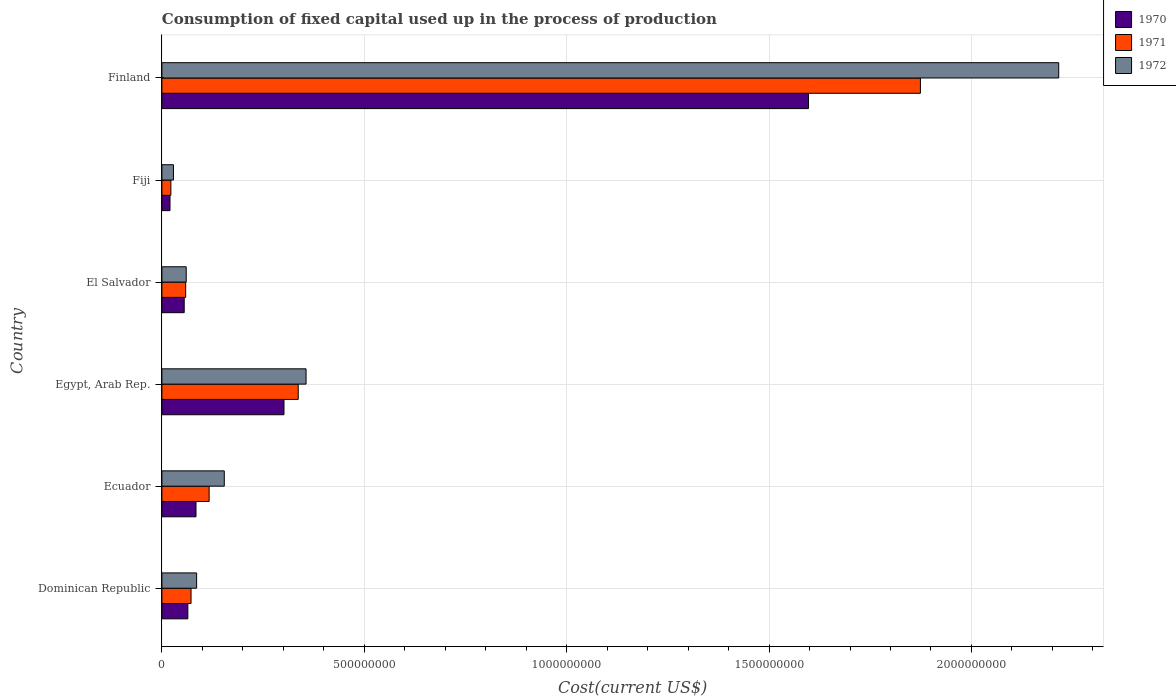How many groups of bars are there?
Your answer should be very brief. 6. What is the label of the 4th group of bars from the top?
Offer a very short reply. Egypt, Arab Rep. In how many cases, is the number of bars for a given country not equal to the number of legend labels?
Make the answer very short. 0. What is the amount consumed in the process of production in 1971 in Ecuador?
Offer a terse response. 1.17e+08. Across all countries, what is the maximum amount consumed in the process of production in 1971?
Ensure brevity in your answer.  1.87e+09. Across all countries, what is the minimum amount consumed in the process of production in 1970?
Provide a succinct answer. 2.00e+07. In which country was the amount consumed in the process of production in 1971 maximum?
Give a very brief answer. Finland. In which country was the amount consumed in the process of production in 1970 minimum?
Make the answer very short. Fiji. What is the total amount consumed in the process of production in 1971 in the graph?
Your answer should be compact. 2.48e+09. What is the difference between the amount consumed in the process of production in 1971 in Ecuador and that in Egypt, Arab Rep.?
Give a very brief answer. -2.20e+08. What is the difference between the amount consumed in the process of production in 1970 in Fiji and the amount consumed in the process of production in 1972 in Egypt, Arab Rep.?
Offer a terse response. -3.36e+08. What is the average amount consumed in the process of production in 1970 per country?
Your answer should be compact. 3.54e+08. What is the difference between the amount consumed in the process of production in 1970 and amount consumed in the process of production in 1971 in Egypt, Arab Rep.?
Your answer should be compact. -3.52e+07. In how many countries, is the amount consumed in the process of production in 1970 greater than 1800000000 US$?
Ensure brevity in your answer.  0. What is the ratio of the amount consumed in the process of production in 1970 in Egypt, Arab Rep. to that in Fiji?
Keep it short and to the point. 15.06. What is the difference between the highest and the second highest amount consumed in the process of production in 1971?
Give a very brief answer. 1.54e+09. What is the difference between the highest and the lowest amount consumed in the process of production in 1970?
Your response must be concise. 1.58e+09. How many bars are there?
Your response must be concise. 18. Does the graph contain any zero values?
Ensure brevity in your answer.  No. Does the graph contain grids?
Keep it short and to the point. Yes. Where does the legend appear in the graph?
Keep it short and to the point. Top right. How are the legend labels stacked?
Provide a succinct answer. Vertical. What is the title of the graph?
Offer a terse response. Consumption of fixed capital used up in the process of production. What is the label or title of the X-axis?
Your answer should be very brief. Cost(current US$). What is the Cost(current US$) in 1970 in Dominican Republic?
Offer a very short reply. 6.41e+07. What is the Cost(current US$) in 1971 in Dominican Republic?
Ensure brevity in your answer.  7.20e+07. What is the Cost(current US$) of 1972 in Dominican Republic?
Make the answer very short. 8.58e+07. What is the Cost(current US$) of 1970 in Ecuador?
Provide a succinct answer. 8.43e+07. What is the Cost(current US$) of 1971 in Ecuador?
Offer a terse response. 1.17e+08. What is the Cost(current US$) of 1972 in Ecuador?
Provide a short and direct response. 1.54e+08. What is the Cost(current US$) of 1970 in Egypt, Arab Rep.?
Your response must be concise. 3.02e+08. What is the Cost(current US$) in 1971 in Egypt, Arab Rep.?
Your answer should be very brief. 3.37e+08. What is the Cost(current US$) of 1972 in Egypt, Arab Rep.?
Provide a short and direct response. 3.56e+08. What is the Cost(current US$) in 1970 in El Salvador?
Keep it short and to the point. 5.51e+07. What is the Cost(current US$) of 1971 in El Salvador?
Ensure brevity in your answer.  5.88e+07. What is the Cost(current US$) of 1972 in El Salvador?
Give a very brief answer. 6.01e+07. What is the Cost(current US$) of 1970 in Fiji?
Ensure brevity in your answer.  2.00e+07. What is the Cost(current US$) of 1971 in Fiji?
Make the answer very short. 2.22e+07. What is the Cost(current US$) in 1972 in Fiji?
Keep it short and to the point. 2.86e+07. What is the Cost(current US$) in 1970 in Finland?
Keep it short and to the point. 1.60e+09. What is the Cost(current US$) in 1971 in Finland?
Provide a short and direct response. 1.87e+09. What is the Cost(current US$) in 1972 in Finland?
Offer a very short reply. 2.22e+09. Across all countries, what is the maximum Cost(current US$) of 1970?
Keep it short and to the point. 1.60e+09. Across all countries, what is the maximum Cost(current US$) of 1971?
Give a very brief answer. 1.87e+09. Across all countries, what is the maximum Cost(current US$) in 1972?
Your answer should be compact. 2.22e+09. Across all countries, what is the minimum Cost(current US$) in 1970?
Give a very brief answer. 2.00e+07. Across all countries, what is the minimum Cost(current US$) of 1971?
Provide a succinct answer. 2.22e+07. Across all countries, what is the minimum Cost(current US$) of 1972?
Provide a short and direct response. 2.86e+07. What is the total Cost(current US$) of 1970 in the graph?
Offer a terse response. 2.12e+09. What is the total Cost(current US$) in 1971 in the graph?
Offer a terse response. 2.48e+09. What is the total Cost(current US$) in 1972 in the graph?
Give a very brief answer. 2.90e+09. What is the difference between the Cost(current US$) of 1970 in Dominican Republic and that in Ecuador?
Provide a short and direct response. -2.01e+07. What is the difference between the Cost(current US$) of 1971 in Dominican Republic and that in Ecuador?
Provide a short and direct response. -4.47e+07. What is the difference between the Cost(current US$) in 1972 in Dominican Republic and that in Ecuador?
Provide a succinct answer. -6.83e+07. What is the difference between the Cost(current US$) of 1970 in Dominican Republic and that in Egypt, Arab Rep.?
Offer a very short reply. -2.37e+08. What is the difference between the Cost(current US$) of 1971 in Dominican Republic and that in Egypt, Arab Rep.?
Provide a succinct answer. -2.65e+08. What is the difference between the Cost(current US$) of 1972 in Dominican Republic and that in Egypt, Arab Rep.?
Provide a short and direct response. -2.70e+08. What is the difference between the Cost(current US$) of 1970 in Dominican Republic and that in El Salvador?
Make the answer very short. 9.05e+06. What is the difference between the Cost(current US$) in 1971 in Dominican Republic and that in El Salvador?
Offer a terse response. 1.32e+07. What is the difference between the Cost(current US$) of 1972 in Dominican Republic and that in El Salvador?
Offer a very short reply. 2.57e+07. What is the difference between the Cost(current US$) of 1970 in Dominican Republic and that in Fiji?
Your answer should be very brief. 4.41e+07. What is the difference between the Cost(current US$) of 1971 in Dominican Republic and that in Fiji?
Give a very brief answer. 4.98e+07. What is the difference between the Cost(current US$) in 1972 in Dominican Republic and that in Fiji?
Your response must be concise. 5.72e+07. What is the difference between the Cost(current US$) in 1970 in Dominican Republic and that in Finland?
Offer a very short reply. -1.53e+09. What is the difference between the Cost(current US$) in 1971 in Dominican Republic and that in Finland?
Give a very brief answer. -1.80e+09. What is the difference between the Cost(current US$) of 1972 in Dominican Republic and that in Finland?
Ensure brevity in your answer.  -2.13e+09. What is the difference between the Cost(current US$) in 1970 in Ecuador and that in Egypt, Arab Rep.?
Offer a very short reply. -2.17e+08. What is the difference between the Cost(current US$) in 1971 in Ecuador and that in Egypt, Arab Rep.?
Make the answer very short. -2.20e+08. What is the difference between the Cost(current US$) in 1972 in Ecuador and that in Egypt, Arab Rep.?
Keep it short and to the point. -2.02e+08. What is the difference between the Cost(current US$) of 1970 in Ecuador and that in El Salvador?
Your answer should be very brief. 2.92e+07. What is the difference between the Cost(current US$) of 1971 in Ecuador and that in El Salvador?
Keep it short and to the point. 5.79e+07. What is the difference between the Cost(current US$) in 1972 in Ecuador and that in El Salvador?
Your answer should be very brief. 9.40e+07. What is the difference between the Cost(current US$) of 1970 in Ecuador and that in Fiji?
Ensure brevity in your answer.  6.42e+07. What is the difference between the Cost(current US$) in 1971 in Ecuador and that in Fiji?
Provide a succinct answer. 9.45e+07. What is the difference between the Cost(current US$) of 1972 in Ecuador and that in Fiji?
Make the answer very short. 1.26e+08. What is the difference between the Cost(current US$) in 1970 in Ecuador and that in Finland?
Offer a very short reply. -1.51e+09. What is the difference between the Cost(current US$) of 1971 in Ecuador and that in Finland?
Your response must be concise. -1.76e+09. What is the difference between the Cost(current US$) of 1972 in Ecuador and that in Finland?
Your answer should be very brief. -2.06e+09. What is the difference between the Cost(current US$) of 1970 in Egypt, Arab Rep. and that in El Salvador?
Your response must be concise. 2.47e+08. What is the difference between the Cost(current US$) in 1971 in Egypt, Arab Rep. and that in El Salvador?
Give a very brief answer. 2.78e+08. What is the difference between the Cost(current US$) of 1972 in Egypt, Arab Rep. and that in El Salvador?
Keep it short and to the point. 2.96e+08. What is the difference between the Cost(current US$) in 1970 in Egypt, Arab Rep. and that in Fiji?
Keep it short and to the point. 2.82e+08. What is the difference between the Cost(current US$) in 1971 in Egypt, Arab Rep. and that in Fiji?
Offer a terse response. 3.15e+08. What is the difference between the Cost(current US$) in 1972 in Egypt, Arab Rep. and that in Fiji?
Make the answer very short. 3.28e+08. What is the difference between the Cost(current US$) of 1970 in Egypt, Arab Rep. and that in Finland?
Your answer should be compact. -1.30e+09. What is the difference between the Cost(current US$) in 1971 in Egypt, Arab Rep. and that in Finland?
Your response must be concise. -1.54e+09. What is the difference between the Cost(current US$) of 1972 in Egypt, Arab Rep. and that in Finland?
Your response must be concise. -1.86e+09. What is the difference between the Cost(current US$) in 1970 in El Salvador and that in Fiji?
Give a very brief answer. 3.51e+07. What is the difference between the Cost(current US$) in 1971 in El Salvador and that in Fiji?
Offer a terse response. 3.66e+07. What is the difference between the Cost(current US$) of 1972 in El Salvador and that in Fiji?
Offer a very short reply. 3.15e+07. What is the difference between the Cost(current US$) of 1970 in El Salvador and that in Finland?
Provide a short and direct response. -1.54e+09. What is the difference between the Cost(current US$) in 1971 in El Salvador and that in Finland?
Your answer should be very brief. -1.82e+09. What is the difference between the Cost(current US$) of 1972 in El Salvador and that in Finland?
Offer a terse response. -2.16e+09. What is the difference between the Cost(current US$) of 1970 in Fiji and that in Finland?
Make the answer very short. -1.58e+09. What is the difference between the Cost(current US$) of 1971 in Fiji and that in Finland?
Offer a very short reply. -1.85e+09. What is the difference between the Cost(current US$) of 1972 in Fiji and that in Finland?
Make the answer very short. -2.19e+09. What is the difference between the Cost(current US$) in 1970 in Dominican Republic and the Cost(current US$) in 1971 in Ecuador?
Your answer should be very brief. -5.25e+07. What is the difference between the Cost(current US$) in 1970 in Dominican Republic and the Cost(current US$) in 1972 in Ecuador?
Ensure brevity in your answer.  -9.00e+07. What is the difference between the Cost(current US$) in 1971 in Dominican Republic and the Cost(current US$) in 1972 in Ecuador?
Offer a very short reply. -8.21e+07. What is the difference between the Cost(current US$) of 1970 in Dominican Republic and the Cost(current US$) of 1971 in Egypt, Arab Rep.?
Ensure brevity in your answer.  -2.73e+08. What is the difference between the Cost(current US$) in 1970 in Dominican Republic and the Cost(current US$) in 1972 in Egypt, Arab Rep.?
Your answer should be compact. -2.92e+08. What is the difference between the Cost(current US$) in 1971 in Dominican Republic and the Cost(current US$) in 1972 in Egypt, Arab Rep.?
Make the answer very short. -2.84e+08. What is the difference between the Cost(current US$) in 1970 in Dominican Republic and the Cost(current US$) in 1971 in El Salvador?
Keep it short and to the point. 5.36e+06. What is the difference between the Cost(current US$) of 1970 in Dominican Republic and the Cost(current US$) of 1972 in El Salvador?
Your answer should be very brief. 4.06e+06. What is the difference between the Cost(current US$) of 1971 in Dominican Republic and the Cost(current US$) of 1972 in El Salvador?
Make the answer very short. 1.19e+07. What is the difference between the Cost(current US$) of 1970 in Dominican Republic and the Cost(current US$) of 1971 in Fiji?
Provide a short and direct response. 4.20e+07. What is the difference between the Cost(current US$) in 1970 in Dominican Republic and the Cost(current US$) in 1972 in Fiji?
Offer a terse response. 3.56e+07. What is the difference between the Cost(current US$) in 1971 in Dominican Republic and the Cost(current US$) in 1972 in Fiji?
Your response must be concise. 4.34e+07. What is the difference between the Cost(current US$) in 1970 in Dominican Republic and the Cost(current US$) in 1971 in Finland?
Give a very brief answer. -1.81e+09. What is the difference between the Cost(current US$) in 1970 in Dominican Republic and the Cost(current US$) in 1972 in Finland?
Offer a terse response. -2.15e+09. What is the difference between the Cost(current US$) in 1971 in Dominican Republic and the Cost(current US$) in 1972 in Finland?
Your response must be concise. -2.14e+09. What is the difference between the Cost(current US$) of 1970 in Ecuador and the Cost(current US$) of 1971 in Egypt, Arab Rep.?
Provide a succinct answer. -2.53e+08. What is the difference between the Cost(current US$) in 1970 in Ecuador and the Cost(current US$) in 1972 in Egypt, Arab Rep.?
Offer a very short reply. -2.72e+08. What is the difference between the Cost(current US$) in 1971 in Ecuador and the Cost(current US$) in 1972 in Egypt, Arab Rep.?
Make the answer very short. -2.39e+08. What is the difference between the Cost(current US$) of 1970 in Ecuador and the Cost(current US$) of 1971 in El Salvador?
Your answer should be very brief. 2.55e+07. What is the difference between the Cost(current US$) of 1970 in Ecuador and the Cost(current US$) of 1972 in El Salvador?
Offer a terse response. 2.42e+07. What is the difference between the Cost(current US$) of 1971 in Ecuador and the Cost(current US$) of 1972 in El Salvador?
Ensure brevity in your answer.  5.66e+07. What is the difference between the Cost(current US$) of 1970 in Ecuador and the Cost(current US$) of 1971 in Fiji?
Your answer should be very brief. 6.21e+07. What is the difference between the Cost(current US$) in 1970 in Ecuador and the Cost(current US$) in 1972 in Fiji?
Offer a terse response. 5.57e+07. What is the difference between the Cost(current US$) of 1971 in Ecuador and the Cost(current US$) of 1972 in Fiji?
Your answer should be very brief. 8.81e+07. What is the difference between the Cost(current US$) of 1970 in Ecuador and the Cost(current US$) of 1971 in Finland?
Your answer should be very brief. -1.79e+09. What is the difference between the Cost(current US$) of 1970 in Ecuador and the Cost(current US$) of 1972 in Finland?
Your answer should be very brief. -2.13e+09. What is the difference between the Cost(current US$) in 1971 in Ecuador and the Cost(current US$) in 1972 in Finland?
Offer a terse response. -2.10e+09. What is the difference between the Cost(current US$) in 1970 in Egypt, Arab Rep. and the Cost(current US$) in 1971 in El Salvador?
Ensure brevity in your answer.  2.43e+08. What is the difference between the Cost(current US$) of 1970 in Egypt, Arab Rep. and the Cost(current US$) of 1972 in El Salvador?
Keep it short and to the point. 2.42e+08. What is the difference between the Cost(current US$) of 1971 in Egypt, Arab Rep. and the Cost(current US$) of 1972 in El Salvador?
Provide a short and direct response. 2.77e+08. What is the difference between the Cost(current US$) in 1970 in Egypt, Arab Rep. and the Cost(current US$) in 1971 in Fiji?
Provide a short and direct response. 2.79e+08. What is the difference between the Cost(current US$) of 1970 in Egypt, Arab Rep. and the Cost(current US$) of 1972 in Fiji?
Offer a very short reply. 2.73e+08. What is the difference between the Cost(current US$) of 1971 in Egypt, Arab Rep. and the Cost(current US$) of 1972 in Fiji?
Provide a short and direct response. 3.08e+08. What is the difference between the Cost(current US$) of 1970 in Egypt, Arab Rep. and the Cost(current US$) of 1971 in Finland?
Your answer should be very brief. -1.57e+09. What is the difference between the Cost(current US$) in 1970 in Egypt, Arab Rep. and the Cost(current US$) in 1972 in Finland?
Keep it short and to the point. -1.91e+09. What is the difference between the Cost(current US$) in 1971 in Egypt, Arab Rep. and the Cost(current US$) in 1972 in Finland?
Provide a succinct answer. -1.88e+09. What is the difference between the Cost(current US$) in 1970 in El Salvador and the Cost(current US$) in 1971 in Fiji?
Your response must be concise. 3.29e+07. What is the difference between the Cost(current US$) of 1970 in El Salvador and the Cost(current US$) of 1972 in Fiji?
Provide a succinct answer. 2.65e+07. What is the difference between the Cost(current US$) in 1971 in El Salvador and the Cost(current US$) in 1972 in Fiji?
Ensure brevity in your answer.  3.02e+07. What is the difference between the Cost(current US$) of 1970 in El Salvador and the Cost(current US$) of 1971 in Finland?
Offer a very short reply. -1.82e+09. What is the difference between the Cost(current US$) in 1970 in El Salvador and the Cost(current US$) in 1972 in Finland?
Your answer should be compact. -2.16e+09. What is the difference between the Cost(current US$) in 1971 in El Salvador and the Cost(current US$) in 1972 in Finland?
Give a very brief answer. -2.16e+09. What is the difference between the Cost(current US$) in 1970 in Fiji and the Cost(current US$) in 1971 in Finland?
Make the answer very short. -1.85e+09. What is the difference between the Cost(current US$) of 1970 in Fiji and the Cost(current US$) of 1972 in Finland?
Your answer should be compact. -2.20e+09. What is the difference between the Cost(current US$) in 1971 in Fiji and the Cost(current US$) in 1972 in Finland?
Provide a succinct answer. -2.19e+09. What is the average Cost(current US$) of 1970 per country?
Your answer should be very brief. 3.54e+08. What is the average Cost(current US$) in 1971 per country?
Your answer should be compact. 4.13e+08. What is the average Cost(current US$) of 1972 per country?
Give a very brief answer. 4.83e+08. What is the difference between the Cost(current US$) in 1970 and Cost(current US$) in 1971 in Dominican Republic?
Keep it short and to the point. -7.86e+06. What is the difference between the Cost(current US$) in 1970 and Cost(current US$) in 1972 in Dominican Republic?
Your answer should be very brief. -2.17e+07. What is the difference between the Cost(current US$) of 1971 and Cost(current US$) of 1972 in Dominican Republic?
Give a very brief answer. -1.38e+07. What is the difference between the Cost(current US$) in 1970 and Cost(current US$) in 1971 in Ecuador?
Your answer should be compact. -3.24e+07. What is the difference between the Cost(current US$) of 1970 and Cost(current US$) of 1972 in Ecuador?
Your response must be concise. -6.99e+07. What is the difference between the Cost(current US$) of 1971 and Cost(current US$) of 1972 in Ecuador?
Offer a terse response. -3.74e+07. What is the difference between the Cost(current US$) in 1970 and Cost(current US$) in 1971 in Egypt, Arab Rep.?
Your answer should be compact. -3.52e+07. What is the difference between the Cost(current US$) in 1970 and Cost(current US$) in 1972 in Egypt, Arab Rep.?
Offer a terse response. -5.45e+07. What is the difference between the Cost(current US$) of 1971 and Cost(current US$) of 1972 in Egypt, Arab Rep.?
Offer a very short reply. -1.93e+07. What is the difference between the Cost(current US$) in 1970 and Cost(current US$) in 1971 in El Salvador?
Your answer should be compact. -3.70e+06. What is the difference between the Cost(current US$) in 1970 and Cost(current US$) in 1972 in El Salvador?
Give a very brief answer. -4.99e+06. What is the difference between the Cost(current US$) of 1971 and Cost(current US$) of 1972 in El Salvador?
Provide a succinct answer. -1.29e+06. What is the difference between the Cost(current US$) of 1970 and Cost(current US$) of 1971 in Fiji?
Your answer should be compact. -2.14e+06. What is the difference between the Cost(current US$) of 1970 and Cost(current US$) of 1972 in Fiji?
Offer a very short reply. -8.53e+06. What is the difference between the Cost(current US$) in 1971 and Cost(current US$) in 1972 in Fiji?
Keep it short and to the point. -6.39e+06. What is the difference between the Cost(current US$) in 1970 and Cost(current US$) in 1971 in Finland?
Provide a short and direct response. -2.77e+08. What is the difference between the Cost(current US$) in 1970 and Cost(current US$) in 1972 in Finland?
Your answer should be compact. -6.18e+08. What is the difference between the Cost(current US$) in 1971 and Cost(current US$) in 1972 in Finland?
Offer a terse response. -3.42e+08. What is the ratio of the Cost(current US$) in 1970 in Dominican Republic to that in Ecuador?
Provide a succinct answer. 0.76. What is the ratio of the Cost(current US$) in 1971 in Dominican Republic to that in Ecuador?
Give a very brief answer. 0.62. What is the ratio of the Cost(current US$) in 1972 in Dominican Republic to that in Ecuador?
Make the answer very short. 0.56. What is the ratio of the Cost(current US$) of 1970 in Dominican Republic to that in Egypt, Arab Rep.?
Provide a succinct answer. 0.21. What is the ratio of the Cost(current US$) of 1971 in Dominican Republic to that in Egypt, Arab Rep.?
Offer a very short reply. 0.21. What is the ratio of the Cost(current US$) in 1972 in Dominican Republic to that in Egypt, Arab Rep.?
Offer a terse response. 0.24. What is the ratio of the Cost(current US$) of 1970 in Dominican Republic to that in El Salvador?
Offer a terse response. 1.16. What is the ratio of the Cost(current US$) of 1971 in Dominican Republic to that in El Salvador?
Offer a terse response. 1.22. What is the ratio of the Cost(current US$) of 1972 in Dominican Republic to that in El Salvador?
Offer a very short reply. 1.43. What is the ratio of the Cost(current US$) in 1970 in Dominican Republic to that in Fiji?
Your answer should be very brief. 3.2. What is the ratio of the Cost(current US$) of 1971 in Dominican Republic to that in Fiji?
Offer a very short reply. 3.25. What is the ratio of the Cost(current US$) of 1972 in Dominican Republic to that in Fiji?
Make the answer very short. 3. What is the ratio of the Cost(current US$) of 1970 in Dominican Republic to that in Finland?
Your answer should be compact. 0.04. What is the ratio of the Cost(current US$) in 1971 in Dominican Republic to that in Finland?
Offer a very short reply. 0.04. What is the ratio of the Cost(current US$) of 1972 in Dominican Republic to that in Finland?
Keep it short and to the point. 0.04. What is the ratio of the Cost(current US$) of 1970 in Ecuador to that in Egypt, Arab Rep.?
Ensure brevity in your answer.  0.28. What is the ratio of the Cost(current US$) of 1971 in Ecuador to that in Egypt, Arab Rep.?
Give a very brief answer. 0.35. What is the ratio of the Cost(current US$) in 1972 in Ecuador to that in Egypt, Arab Rep.?
Your response must be concise. 0.43. What is the ratio of the Cost(current US$) of 1970 in Ecuador to that in El Salvador?
Your response must be concise. 1.53. What is the ratio of the Cost(current US$) in 1971 in Ecuador to that in El Salvador?
Give a very brief answer. 1.98. What is the ratio of the Cost(current US$) of 1972 in Ecuador to that in El Salvador?
Offer a very short reply. 2.57. What is the ratio of the Cost(current US$) in 1970 in Ecuador to that in Fiji?
Offer a very short reply. 4.21. What is the ratio of the Cost(current US$) in 1971 in Ecuador to that in Fiji?
Make the answer very short. 5.26. What is the ratio of the Cost(current US$) in 1972 in Ecuador to that in Fiji?
Give a very brief answer. 5.4. What is the ratio of the Cost(current US$) of 1970 in Ecuador to that in Finland?
Offer a very short reply. 0.05. What is the ratio of the Cost(current US$) in 1971 in Ecuador to that in Finland?
Give a very brief answer. 0.06. What is the ratio of the Cost(current US$) in 1972 in Ecuador to that in Finland?
Your answer should be compact. 0.07. What is the ratio of the Cost(current US$) in 1970 in Egypt, Arab Rep. to that in El Salvador?
Provide a succinct answer. 5.48. What is the ratio of the Cost(current US$) in 1971 in Egypt, Arab Rep. to that in El Salvador?
Make the answer very short. 5.73. What is the ratio of the Cost(current US$) of 1972 in Egypt, Arab Rep. to that in El Salvador?
Offer a very short reply. 5.93. What is the ratio of the Cost(current US$) in 1970 in Egypt, Arab Rep. to that in Fiji?
Provide a succinct answer. 15.06. What is the ratio of the Cost(current US$) in 1971 in Egypt, Arab Rep. to that in Fiji?
Ensure brevity in your answer.  15.2. What is the ratio of the Cost(current US$) of 1972 in Egypt, Arab Rep. to that in Fiji?
Give a very brief answer. 12.47. What is the ratio of the Cost(current US$) in 1970 in Egypt, Arab Rep. to that in Finland?
Give a very brief answer. 0.19. What is the ratio of the Cost(current US$) in 1971 in Egypt, Arab Rep. to that in Finland?
Offer a very short reply. 0.18. What is the ratio of the Cost(current US$) of 1972 in Egypt, Arab Rep. to that in Finland?
Offer a terse response. 0.16. What is the ratio of the Cost(current US$) of 1970 in El Salvador to that in Fiji?
Make the answer very short. 2.75. What is the ratio of the Cost(current US$) of 1971 in El Salvador to that in Fiji?
Provide a succinct answer. 2.65. What is the ratio of the Cost(current US$) of 1972 in El Salvador to that in Fiji?
Provide a short and direct response. 2.1. What is the ratio of the Cost(current US$) in 1970 in El Salvador to that in Finland?
Your answer should be very brief. 0.03. What is the ratio of the Cost(current US$) of 1971 in El Salvador to that in Finland?
Your answer should be very brief. 0.03. What is the ratio of the Cost(current US$) of 1972 in El Salvador to that in Finland?
Your answer should be compact. 0.03. What is the ratio of the Cost(current US$) of 1970 in Fiji to that in Finland?
Offer a very short reply. 0.01. What is the ratio of the Cost(current US$) in 1971 in Fiji to that in Finland?
Ensure brevity in your answer.  0.01. What is the ratio of the Cost(current US$) in 1972 in Fiji to that in Finland?
Keep it short and to the point. 0.01. What is the difference between the highest and the second highest Cost(current US$) of 1970?
Keep it short and to the point. 1.30e+09. What is the difference between the highest and the second highest Cost(current US$) of 1971?
Ensure brevity in your answer.  1.54e+09. What is the difference between the highest and the second highest Cost(current US$) in 1972?
Your answer should be very brief. 1.86e+09. What is the difference between the highest and the lowest Cost(current US$) in 1970?
Ensure brevity in your answer.  1.58e+09. What is the difference between the highest and the lowest Cost(current US$) in 1971?
Offer a terse response. 1.85e+09. What is the difference between the highest and the lowest Cost(current US$) of 1972?
Provide a short and direct response. 2.19e+09. 